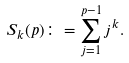Convert formula to latex. <formula><loc_0><loc_0><loc_500><loc_500>S _ { k } ( p ) \colon = \sum _ { j = 1 } ^ { p - 1 } j ^ { k } .</formula> 